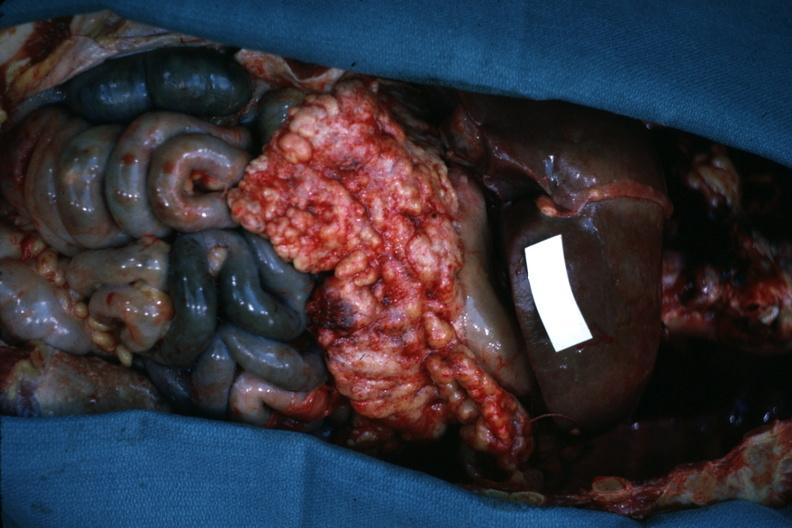where is this area in the body?
Answer the question using a single word or phrase. Abdomen 